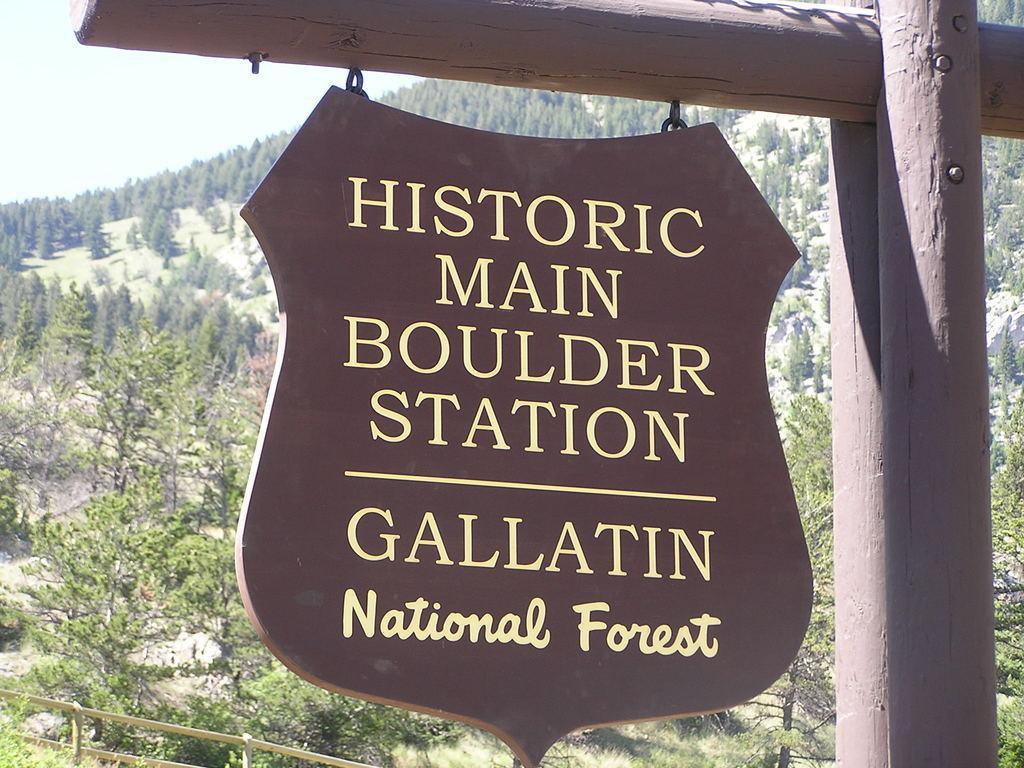Describe this image in one or two sentences. In this image there is a wooden board which is hanging to the wooden stick. In the background there is a forest with the trees and plants. On the right side there is a wooden pole. 